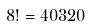<formula> <loc_0><loc_0><loc_500><loc_500>8 ! = 4 0 3 2 0</formula> 